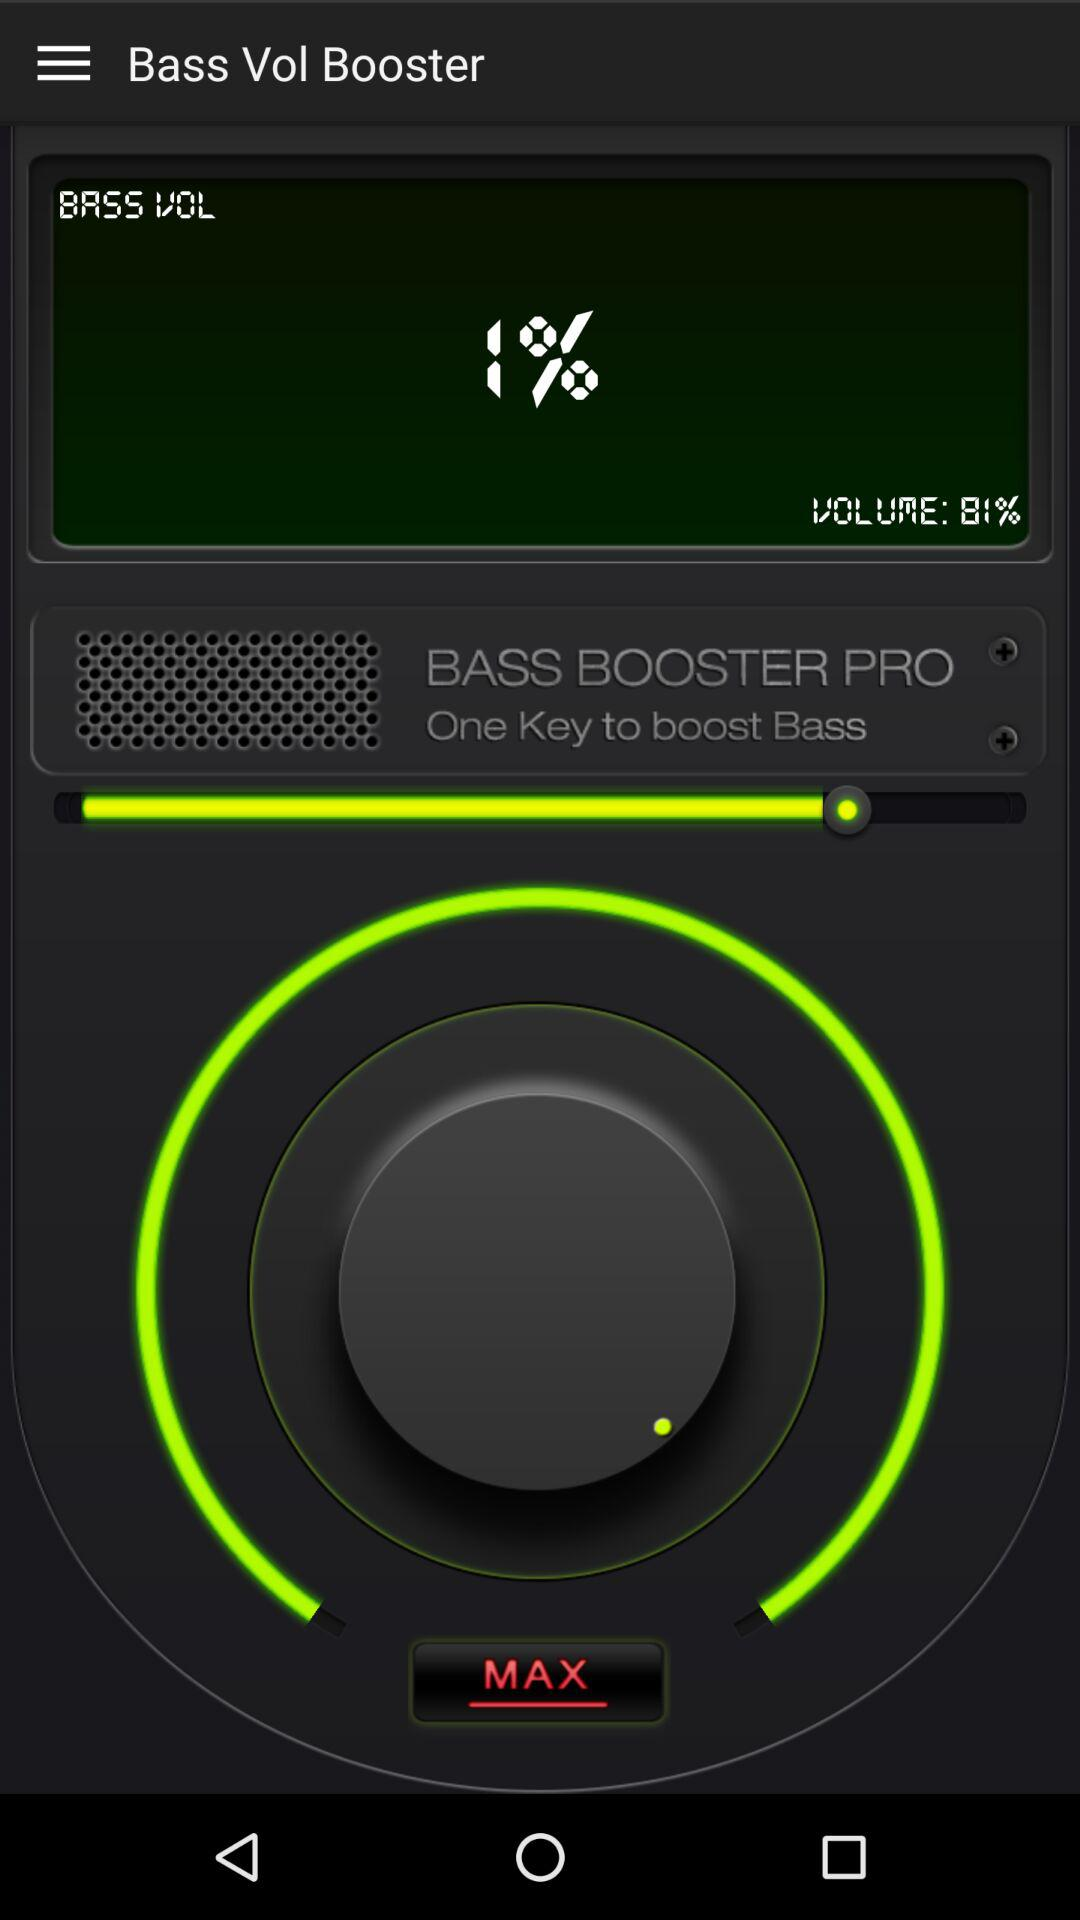What's the volume percentage? The volume percentage is 81. 